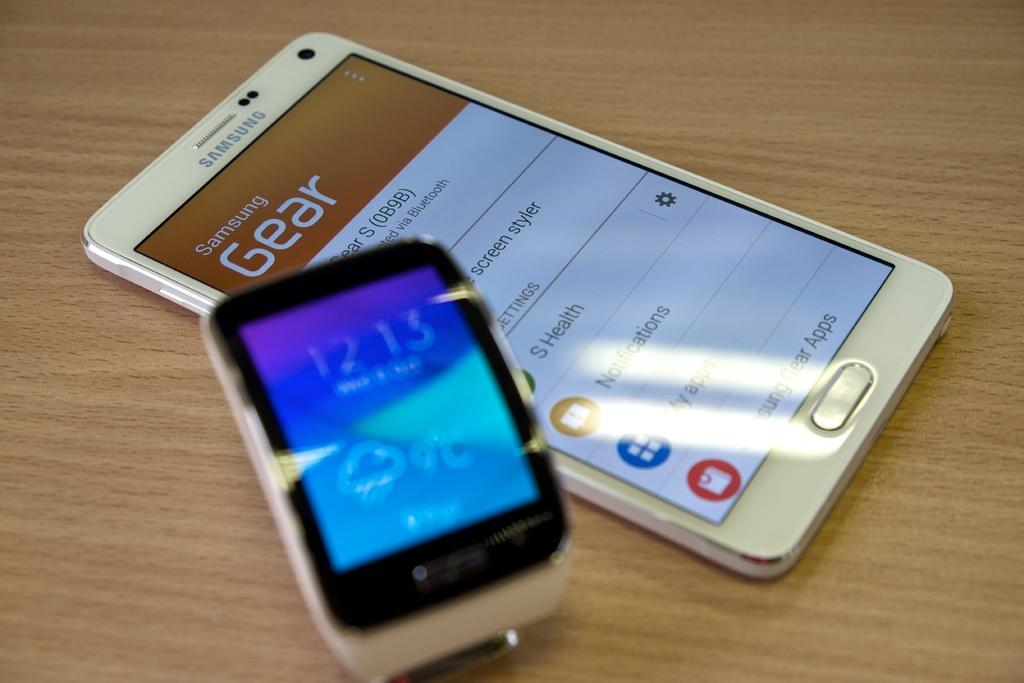<image>
Offer a succinct explanation of the picture presented. A white Samsung phone next to a smart watch. 